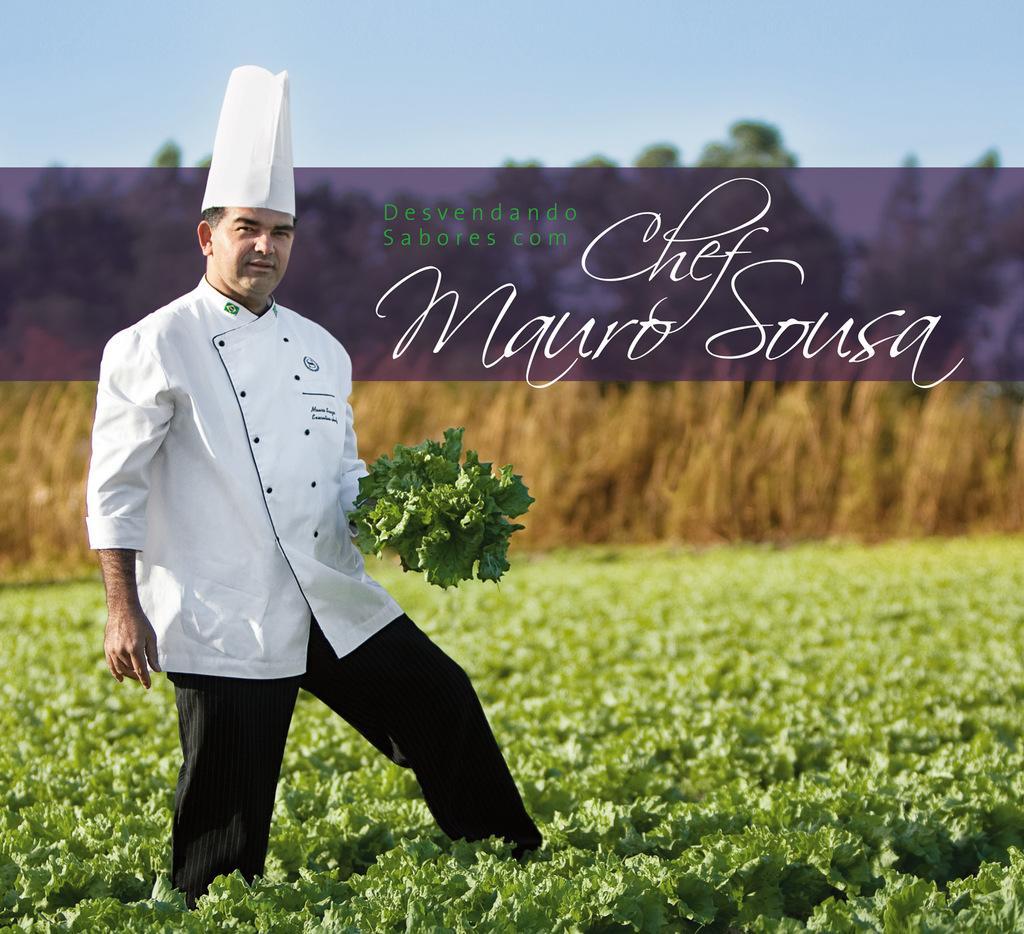Describe this image in one or two sentences. This image is an edited image. This image is taken outdoors. At the top of the image there is the sky. In the background there are many trees. On the left side of the image a man is standing and he is holding a few leaves in his hand. There are many plants with green leaves and stems. 